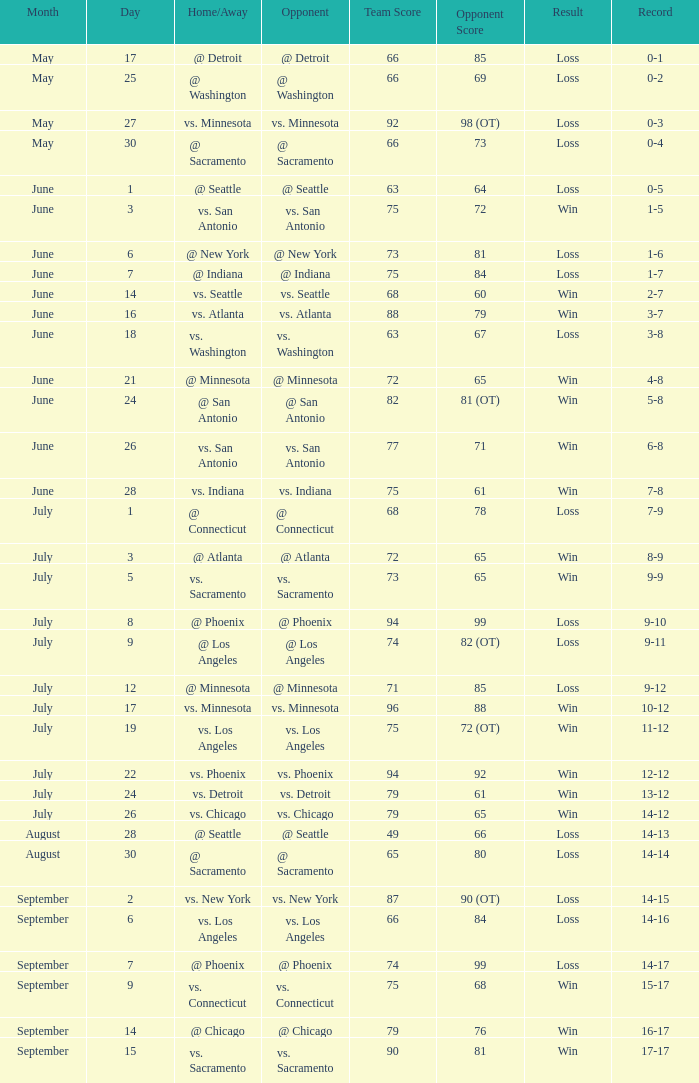I'm looking to parse the entire table for insights. Could you assist me with that? {'header': ['Month', 'Day', 'Home/Away', 'Opponent', 'Team Score', 'Opponent Score', 'Result', 'Record'], 'rows': [['May', '17', '@ Detroit', '@ Detroit', '66', '85', 'Loss', '0-1'], ['May', '25', '@ Washington', '@ Washington', '66', '69', 'Loss', '0-2'], ['May', '27', 'vs. Minnesota', 'vs. Minnesota', '92', '98 (OT)', 'Loss', '0-3'], ['May', '30', '@ Sacramento', '@ Sacramento', '66', '73', 'Loss', '0-4'], ['June', '1', '@ Seattle', '@ Seattle', '63', '64', 'Loss', '0-5'], ['June', '3', 'vs. San Antonio', 'vs. San Antonio', '75', '72', 'Win', '1-5'], ['June', '6', '@ New York', '@ New York', '73', '81', 'Loss', '1-6'], ['June', '7', '@ Indiana', '@ Indiana', '75', '84', 'Loss', '1-7'], ['June', '14', 'vs. Seattle', 'vs. Seattle', '68', '60', 'Win', '2-7'], ['June', '16', 'vs. Atlanta', 'vs. Atlanta', '88', '79', 'Win', '3-7'], ['June', '18', 'vs. Washington', 'vs. Washington', '63', '67', 'Loss', '3-8'], ['June', '21', '@ Minnesota', '@ Minnesota', '72', '65', 'Win', '4-8'], ['June', '24', '@ San Antonio', '@ San Antonio', '82', '81 (OT)', 'Win', '5-8'], ['June', '26', 'vs. San Antonio', 'vs. San Antonio', '77', '71', 'Win', '6-8'], ['June', '28', 'vs. Indiana', 'vs. Indiana', '75', '61', 'Win', '7-8'], ['July', '1', '@ Connecticut', '@ Connecticut', '68', '78', 'Loss', '7-9'], ['July', '3', '@ Atlanta', '@ Atlanta', '72', '65', 'Win', '8-9'], ['July', '5', 'vs. Sacramento', 'vs. Sacramento', '73', '65', 'Win', '9-9'], ['July', '8', '@ Phoenix', '@ Phoenix', '94', '99', 'Loss', '9-10'], ['July', '9', '@ Los Angeles', '@ Los Angeles', '74', '82 (OT)', 'Loss', '9-11'], ['July', '12', '@ Minnesota', '@ Minnesota', '71', '85', 'Loss', '9-12'], ['July', '17', 'vs. Minnesota', 'vs. Minnesota', '96', '88', 'Win', '10-12'], ['July', '19', 'vs. Los Angeles', 'vs. Los Angeles', '75', '72 (OT)', 'Win', '11-12'], ['July', '22', 'vs. Phoenix', 'vs. Phoenix', '94', '92', 'Win', '12-12'], ['July', '24', 'vs. Detroit', 'vs. Detroit', '79', '61', 'Win', '13-12'], ['July', '26', 'vs. Chicago', 'vs. Chicago', '79', '65', 'Win', '14-12'], ['August', '28', '@ Seattle', '@ Seattle', '49', '66', 'Loss', '14-13'], ['August', '30', '@ Sacramento', '@ Sacramento', '65', '80', 'Loss', '14-14'], ['September', '2', 'vs. New York', 'vs. New York', '87', '90 (OT)', 'Loss', '14-15'], ['September', '6', 'vs. Los Angeles', 'vs. Los Angeles', '66', '84', 'Loss', '14-16'], ['September', '7', '@ Phoenix', '@ Phoenix', '74', '99', 'Loss', '14-17'], ['September', '9', 'vs. Connecticut', 'vs. Connecticut', '75', '68', 'Win', '15-17'], ['September', '14', '@ Chicago', '@ Chicago', '79', '76', 'Win', '16-17'], ['September', '15', 'vs. Sacramento', 'vs. Sacramento', '90', '81', 'Win', '17-17']]} What is the Record on July 12? 9-12. 